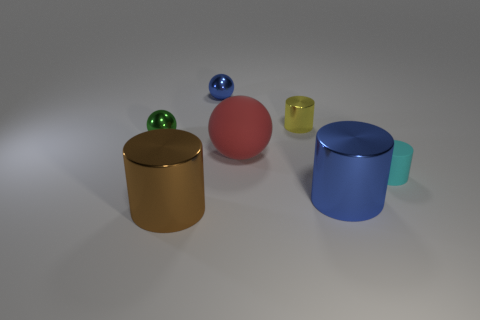Is the size of the shiny cylinder in front of the big blue metallic object the same as the object on the right side of the blue shiny cylinder?
Your answer should be compact. No. Is the number of tiny metal spheres to the right of the brown cylinder greater than the number of tiny green objects on the right side of the large blue cylinder?
Your answer should be very brief. Yes. What number of small green metallic objects have the same shape as the tiny blue shiny object?
Keep it short and to the point. 1. What is the material of the green thing that is the same size as the blue sphere?
Make the answer very short. Metal. Is there a brown thing made of the same material as the big brown cylinder?
Provide a short and direct response. No. Is the number of things that are in front of the tiny matte cylinder less than the number of tiny yellow shiny things?
Offer a very short reply. No. There is a small cyan cylinder that is to the right of the thing that is in front of the large blue metallic object; what is it made of?
Offer a very short reply. Rubber. There is a tiny thing that is behind the large red sphere and in front of the yellow cylinder; what is its shape?
Offer a terse response. Sphere. How many things are large cylinders right of the big brown object or cyan things?
Ensure brevity in your answer.  2. There is a rubber cylinder; is its color the same as the metal cylinder that is behind the small cyan matte cylinder?
Offer a very short reply. No. 